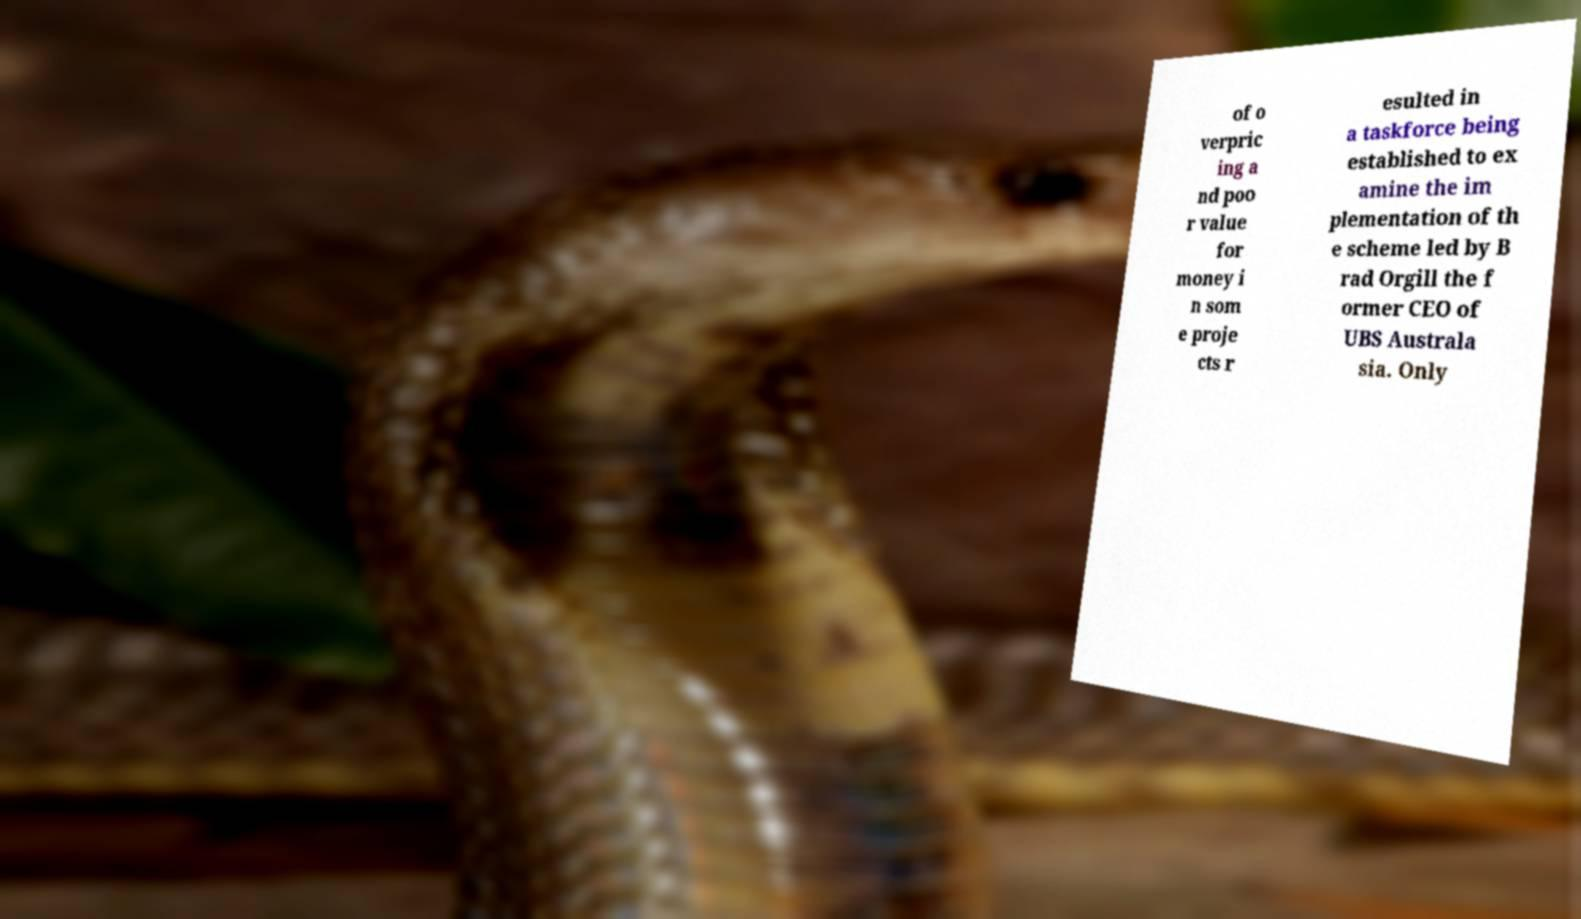For documentation purposes, I need the text within this image transcribed. Could you provide that? of o verpric ing a nd poo r value for money i n som e proje cts r esulted in a taskforce being established to ex amine the im plementation of th e scheme led by B rad Orgill the f ormer CEO of UBS Australa sia. Only 